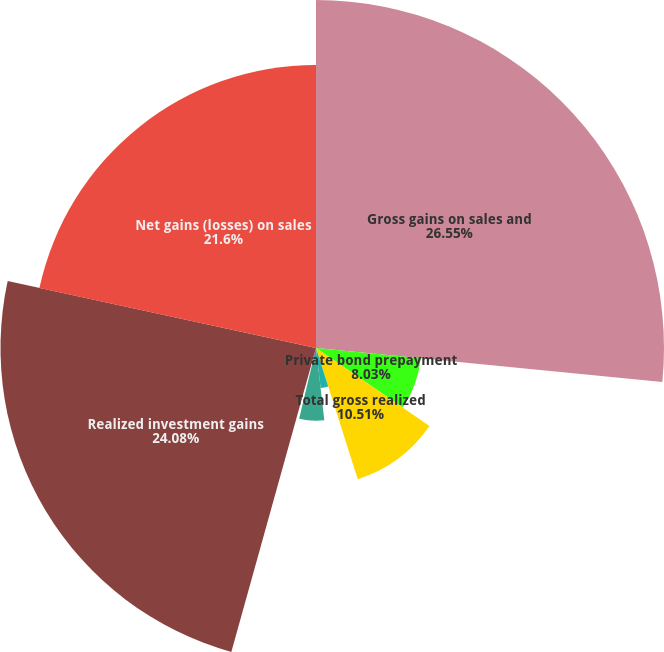<chart> <loc_0><loc_0><loc_500><loc_500><pie_chart><fcel>Gross gains on sales and<fcel>Private bond prepayment<fcel>Total gross realized<fcel>Net OTTI recognized in<fcel>Gross losses on sales and<fcel>Credit related losses on sales<fcel>Realized investment gains<fcel>Net gains (losses) on sales<nl><fcel>26.56%<fcel>8.03%<fcel>10.51%<fcel>3.08%<fcel>5.55%<fcel>0.6%<fcel>24.08%<fcel>21.6%<nl></chart> 